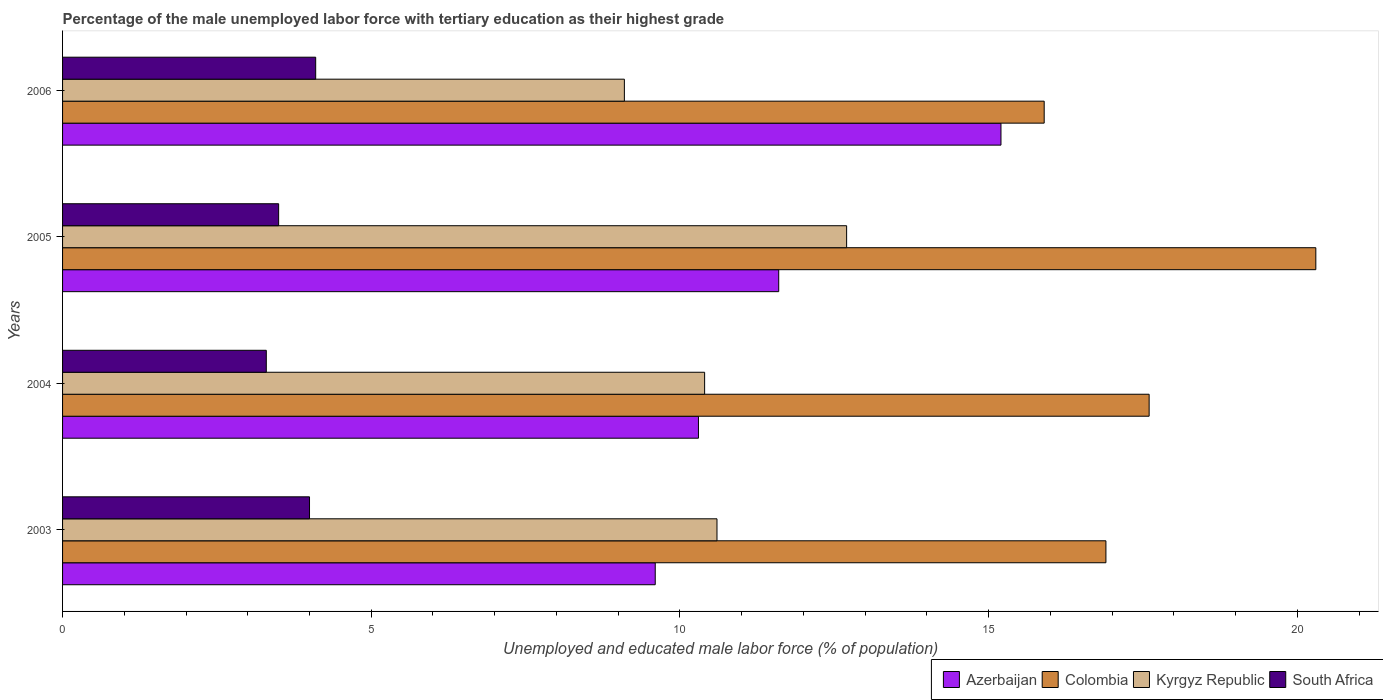How many groups of bars are there?
Your response must be concise. 4. Are the number of bars on each tick of the Y-axis equal?
Your answer should be very brief. Yes. How many bars are there on the 1st tick from the top?
Your response must be concise. 4. Across all years, what is the maximum percentage of the unemployed male labor force with tertiary education in Colombia?
Make the answer very short. 20.3. Across all years, what is the minimum percentage of the unemployed male labor force with tertiary education in South Africa?
Offer a terse response. 3.3. In which year was the percentage of the unemployed male labor force with tertiary education in Kyrgyz Republic maximum?
Your response must be concise. 2005. In which year was the percentage of the unemployed male labor force with tertiary education in Colombia minimum?
Your answer should be very brief. 2006. What is the total percentage of the unemployed male labor force with tertiary education in Kyrgyz Republic in the graph?
Offer a very short reply. 42.8. What is the difference between the percentage of the unemployed male labor force with tertiary education in Azerbaijan in 2005 and that in 2006?
Your answer should be very brief. -3.6. What is the difference between the percentage of the unemployed male labor force with tertiary education in Kyrgyz Republic in 2005 and the percentage of the unemployed male labor force with tertiary education in Azerbaijan in 2003?
Your answer should be compact. 3.1. What is the average percentage of the unemployed male labor force with tertiary education in Azerbaijan per year?
Offer a terse response. 11.68. In the year 2005, what is the difference between the percentage of the unemployed male labor force with tertiary education in Azerbaijan and percentage of the unemployed male labor force with tertiary education in Colombia?
Offer a very short reply. -8.7. In how many years, is the percentage of the unemployed male labor force with tertiary education in Kyrgyz Republic greater than 1 %?
Offer a very short reply. 4. What is the ratio of the percentage of the unemployed male labor force with tertiary education in Kyrgyz Republic in 2003 to that in 2004?
Make the answer very short. 1.02. Is the percentage of the unemployed male labor force with tertiary education in Colombia in 2004 less than that in 2006?
Provide a succinct answer. No. What is the difference between the highest and the second highest percentage of the unemployed male labor force with tertiary education in Colombia?
Ensure brevity in your answer.  2.7. What is the difference between the highest and the lowest percentage of the unemployed male labor force with tertiary education in Azerbaijan?
Your answer should be compact. 5.6. In how many years, is the percentage of the unemployed male labor force with tertiary education in Kyrgyz Republic greater than the average percentage of the unemployed male labor force with tertiary education in Kyrgyz Republic taken over all years?
Offer a terse response. 1. Is it the case that in every year, the sum of the percentage of the unemployed male labor force with tertiary education in Azerbaijan and percentage of the unemployed male labor force with tertiary education in Colombia is greater than the sum of percentage of the unemployed male labor force with tertiary education in South Africa and percentage of the unemployed male labor force with tertiary education in Kyrgyz Republic?
Provide a succinct answer. No. What does the 2nd bar from the top in 2006 represents?
Your answer should be very brief. Kyrgyz Republic. What does the 1st bar from the bottom in 2006 represents?
Give a very brief answer. Azerbaijan. Are all the bars in the graph horizontal?
Make the answer very short. Yes. What is the difference between two consecutive major ticks on the X-axis?
Keep it short and to the point. 5. Are the values on the major ticks of X-axis written in scientific E-notation?
Provide a short and direct response. No. How many legend labels are there?
Your answer should be compact. 4. How are the legend labels stacked?
Provide a short and direct response. Horizontal. What is the title of the graph?
Keep it short and to the point. Percentage of the male unemployed labor force with tertiary education as their highest grade. What is the label or title of the X-axis?
Your answer should be very brief. Unemployed and educated male labor force (% of population). What is the label or title of the Y-axis?
Keep it short and to the point. Years. What is the Unemployed and educated male labor force (% of population) in Azerbaijan in 2003?
Your answer should be compact. 9.6. What is the Unemployed and educated male labor force (% of population) of Colombia in 2003?
Make the answer very short. 16.9. What is the Unemployed and educated male labor force (% of population) in Kyrgyz Republic in 2003?
Your answer should be very brief. 10.6. What is the Unemployed and educated male labor force (% of population) in South Africa in 2003?
Your answer should be compact. 4. What is the Unemployed and educated male labor force (% of population) of Azerbaijan in 2004?
Ensure brevity in your answer.  10.3. What is the Unemployed and educated male labor force (% of population) of Colombia in 2004?
Give a very brief answer. 17.6. What is the Unemployed and educated male labor force (% of population) in Kyrgyz Republic in 2004?
Give a very brief answer. 10.4. What is the Unemployed and educated male labor force (% of population) of South Africa in 2004?
Keep it short and to the point. 3.3. What is the Unemployed and educated male labor force (% of population) in Azerbaijan in 2005?
Keep it short and to the point. 11.6. What is the Unemployed and educated male labor force (% of population) of Colombia in 2005?
Offer a terse response. 20.3. What is the Unemployed and educated male labor force (% of population) of Kyrgyz Republic in 2005?
Your answer should be very brief. 12.7. What is the Unemployed and educated male labor force (% of population) of Azerbaijan in 2006?
Your response must be concise. 15.2. What is the Unemployed and educated male labor force (% of population) of Colombia in 2006?
Your answer should be very brief. 15.9. What is the Unemployed and educated male labor force (% of population) in Kyrgyz Republic in 2006?
Offer a terse response. 9.1. What is the Unemployed and educated male labor force (% of population) in South Africa in 2006?
Keep it short and to the point. 4.1. Across all years, what is the maximum Unemployed and educated male labor force (% of population) of Azerbaijan?
Provide a short and direct response. 15.2. Across all years, what is the maximum Unemployed and educated male labor force (% of population) of Colombia?
Make the answer very short. 20.3. Across all years, what is the maximum Unemployed and educated male labor force (% of population) in Kyrgyz Republic?
Provide a succinct answer. 12.7. Across all years, what is the maximum Unemployed and educated male labor force (% of population) in South Africa?
Give a very brief answer. 4.1. Across all years, what is the minimum Unemployed and educated male labor force (% of population) in Azerbaijan?
Provide a short and direct response. 9.6. Across all years, what is the minimum Unemployed and educated male labor force (% of population) in Colombia?
Provide a succinct answer. 15.9. Across all years, what is the minimum Unemployed and educated male labor force (% of population) of Kyrgyz Republic?
Give a very brief answer. 9.1. Across all years, what is the minimum Unemployed and educated male labor force (% of population) of South Africa?
Provide a succinct answer. 3.3. What is the total Unemployed and educated male labor force (% of population) in Azerbaijan in the graph?
Provide a short and direct response. 46.7. What is the total Unemployed and educated male labor force (% of population) of Colombia in the graph?
Give a very brief answer. 70.7. What is the total Unemployed and educated male labor force (% of population) of Kyrgyz Republic in the graph?
Give a very brief answer. 42.8. What is the total Unemployed and educated male labor force (% of population) in South Africa in the graph?
Offer a very short reply. 14.9. What is the difference between the Unemployed and educated male labor force (% of population) in Azerbaijan in 2003 and that in 2004?
Keep it short and to the point. -0.7. What is the difference between the Unemployed and educated male labor force (% of population) of Kyrgyz Republic in 2003 and that in 2005?
Give a very brief answer. -2.1. What is the difference between the Unemployed and educated male labor force (% of population) of South Africa in 2003 and that in 2005?
Your response must be concise. 0.5. What is the difference between the Unemployed and educated male labor force (% of population) of Azerbaijan in 2003 and that in 2006?
Your answer should be very brief. -5.6. What is the difference between the Unemployed and educated male labor force (% of population) in Azerbaijan in 2004 and that in 2005?
Your response must be concise. -1.3. What is the difference between the Unemployed and educated male labor force (% of population) of Colombia in 2004 and that in 2005?
Your response must be concise. -2.7. What is the difference between the Unemployed and educated male labor force (% of population) in Kyrgyz Republic in 2004 and that in 2005?
Offer a terse response. -2.3. What is the difference between the Unemployed and educated male labor force (% of population) in South Africa in 2004 and that in 2005?
Provide a short and direct response. -0.2. What is the difference between the Unemployed and educated male labor force (% of population) of Azerbaijan in 2004 and that in 2006?
Make the answer very short. -4.9. What is the difference between the Unemployed and educated male labor force (% of population) in Colombia in 2004 and that in 2006?
Ensure brevity in your answer.  1.7. What is the difference between the Unemployed and educated male labor force (% of population) in South Africa in 2004 and that in 2006?
Provide a succinct answer. -0.8. What is the difference between the Unemployed and educated male labor force (% of population) in Azerbaijan in 2005 and that in 2006?
Offer a very short reply. -3.6. What is the difference between the Unemployed and educated male labor force (% of population) of South Africa in 2005 and that in 2006?
Your response must be concise. -0.6. What is the difference between the Unemployed and educated male labor force (% of population) in Azerbaijan in 2003 and the Unemployed and educated male labor force (% of population) in South Africa in 2004?
Your response must be concise. 6.3. What is the difference between the Unemployed and educated male labor force (% of population) of Colombia in 2003 and the Unemployed and educated male labor force (% of population) of Kyrgyz Republic in 2004?
Provide a succinct answer. 6.5. What is the difference between the Unemployed and educated male labor force (% of population) of Colombia in 2003 and the Unemployed and educated male labor force (% of population) of South Africa in 2004?
Provide a succinct answer. 13.6. What is the difference between the Unemployed and educated male labor force (% of population) of Azerbaijan in 2003 and the Unemployed and educated male labor force (% of population) of Kyrgyz Republic in 2005?
Your answer should be very brief. -3.1. What is the difference between the Unemployed and educated male labor force (% of population) of Azerbaijan in 2003 and the Unemployed and educated male labor force (% of population) of South Africa in 2005?
Give a very brief answer. 6.1. What is the difference between the Unemployed and educated male labor force (% of population) of Colombia in 2003 and the Unemployed and educated male labor force (% of population) of South Africa in 2005?
Make the answer very short. 13.4. What is the difference between the Unemployed and educated male labor force (% of population) of Kyrgyz Republic in 2003 and the Unemployed and educated male labor force (% of population) of South Africa in 2005?
Ensure brevity in your answer.  7.1. What is the difference between the Unemployed and educated male labor force (% of population) of Azerbaijan in 2003 and the Unemployed and educated male labor force (% of population) of Colombia in 2006?
Keep it short and to the point. -6.3. What is the difference between the Unemployed and educated male labor force (% of population) of Azerbaijan in 2003 and the Unemployed and educated male labor force (% of population) of Kyrgyz Republic in 2006?
Your response must be concise. 0.5. What is the difference between the Unemployed and educated male labor force (% of population) in Colombia in 2003 and the Unemployed and educated male labor force (% of population) in South Africa in 2006?
Provide a short and direct response. 12.8. What is the difference between the Unemployed and educated male labor force (% of population) in Azerbaijan in 2004 and the Unemployed and educated male labor force (% of population) in South Africa in 2005?
Provide a succinct answer. 6.8. What is the difference between the Unemployed and educated male labor force (% of population) in Colombia in 2004 and the Unemployed and educated male labor force (% of population) in Kyrgyz Republic in 2005?
Make the answer very short. 4.9. What is the difference between the Unemployed and educated male labor force (% of population) in Azerbaijan in 2004 and the Unemployed and educated male labor force (% of population) in Kyrgyz Republic in 2006?
Your response must be concise. 1.2. What is the difference between the Unemployed and educated male labor force (% of population) in Colombia in 2004 and the Unemployed and educated male labor force (% of population) in South Africa in 2006?
Make the answer very short. 13.5. What is the difference between the Unemployed and educated male labor force (% of population) of Azerbaijan in 2005 and the Unemployed and educated male labor force (% of population) of Colombia in 2006?
Provide a short and direct response. -4.3. What is the difference between the Unemployed and educated male labor force (% of population) in Azerbaijan in 2005 and the Unemployed and educated male labor force (% of population) in South Africa in 2006?
Offer a terse response. 7.5. What is the difference between the Unemployed and educated male labor force (% of population) of Colombia in 2005 and the Unemployed and educated male labor force (% of population) of South Africa in 2006?
Provide a succinct answer. 16.2. What is the difference between the Unemployed and educated male labor force (% of population) of Kyrgyz Republic in 2005 and the Unemployed and educated male labor force (% of population) of South Africa in 2006?
Make the answer very short. 8.6. What is the average Unemployed and educated male labor force (% of population) of Azerbaijan per year?
Offer a very short reply. 11.68. What is the average Unemployed and educated male labor force (% of population) of Colombia per year?
Ensure brevity in your answer.  17.68. What is the average Unemployed and educated male labor force (% of population) in South Africa per year?
Your answer should be very brief. 3.73. In the year 2003, what is the difference between the Unemployed and educated male labor force (% of population) of Azerbaijan and Unemployed and educated male labor force (% of population) of Colombia?
Provide a short and direct response. -7.3. In the year 2003, what is the difference between the Unemployed and educated male labor force (% of population) of Azerbaijan and Unemployed and educated male labor force (% of population) of Kyrgyz Republic?
Your answer should be very brief. -1. In the year 2003, what is the difference between the Unemployed and educated male labor force (% of population) in Azerbaijan and Unemployed and educated male labor force (% of population) in South Africa?
Your response must be concise. 5.6. In the year 2003, what is the difference between the Unemployed and educated male labor force (% of population) in Colombia and Unemployed and educated male labor force (% of population) in Kyrgyz Republic?
Make the answer very short. 6.3. In the year 2003, what is the difference between the Unemployed and educated male labor force (% of population) of Colombia and Unemployed and educated male labor force (% of population) of South Africa?
Offer a very short reply. 12.9. In the year 2003, what is the difference between the Unemployed and educated male labor force (% of population) of Kyrgyz Republic and Unemployed and educated male labor force (% of population) of South Africa?
Give a very brief answer. 6.6. In the year 2004, what is the difference between the Unemployed and educated male labor force (% of population) in Colombia and Unemployed and educated male labor force (% of population) in Kyrgyz Republic?
Your answer should be very brief. 7.2. In the year 2004, what is the difference between the Unemployed and educated male labor force (% of population) of Colombia and Unemployed and educated male labor force (% of population) of South Africa?
Offer a terse response. 14.3. In the year 2004, what is the difference between the Unemployed and educated male labor force (% of population) of Kyrgyz Republic and Unemployed and educated male labor force (% of population) of South Africa?
Your answer should be compact. 7.1. In the year 2005, what is the difference between the Unemployed and educated male labor force (% of population) in Azerbaijan and Unemployed and educated male labor force (% of population) in Kyrgyz Republic?
Your response must be concise. -1.1. In the year 2005, what is the difference between the Unemployed and educated male labor force (% of population) of Colombia and Unemployed and educated male labor force (% of population) of Kyrgyz Republic?
Give a very brief answer. 7.6. In the year 2005, what is the difference between the Unemployed and educated male labor force (% of population) in Colombia and Unemployed and educated male labor force (% of population) in South Africa?
Offer a very short reply. 16.8. In the year 2005, what is the difference between the Unemployed and educated male labor force (% of population) of Kyrgyz Republic and Unemployed and educated male labor force (% of population) of South Africa?
Your answer should be compact. 9.2. In the year 2006, what is the difference between the Unemployed and educated male labor force (% of population) in Azerbaijan and Unemployed and educated male labor force (% of population) in Colombia?
Provide a succinct answer. -0.7. In the year 2006, what is the difference between the Unemployed and educated male labor force (% of population) of Azerbaijan and Unemployed and educated male labor force (% of population) of Kyrgyz Republic?
Keep it short and to the point. 6.1. In the year 2006, what is the difference between the Unemployed and educated male labor force (% of population) of Azerbaijan and Unemployed and educated male labor force (% of population) of South Africa?
Your response must be concise. 11.1. What is the ratio of the Unemployed and educated male labor force (% of population) of Azerbaijan in 2003 to that in 2004?
Provide a succinct answer. 0.93. What is the ratio of the Unemployed and educated male labor force (% of population) of Colombia in 2003 to that in 2004?
Make the answer very short. 0.96. What is the ratio of the Unemployed and educated male labor force (% of population) of Kyrgyz Republic in 2003 to that in 2004?
Make the answer very short. 1.02. What is the ratio of the Unemployed and educated male labor force (% of population) in South Africa in 2003 to that in 2004?
Keep it short and to the point. 1.21. What is the ratio of the Unemployed and educated male labor force (% of population) of Azerbaijan in 2003 to that in 2005?
Make the answer very short. 0.83. What is the ratio of the Unemployed and educated male labor force (% of population) in Colombia in 2003 to that in 2005?
Give a very brief answer. 0.83. What is the ratio of the Unemployed and educated male labor force (% of population) of Kyrgyz Republic in 2003 to that in 2005?
Provide a short and direct response. 0.83. What is the ratio of the Unemployed and educated male labor force (% of population) in Azerbaijan in 2003 to that in 2006?
Your answer should be compact. 0.63. What is the ratio of the Unemployed and educated male labor force (% of population) in Colombia in 2003 to that in 2006?
Make the answer very short. 1.06. What is the ratio of the Unemployed and educated male labor force (% of population) in Kyrgyz Republic in 2003 to that in 2006?
Your answer should be very brief. 1.16. What is the ratio of the Unemployed and educated male labor force (% of population) of South Africa in 2003 to that in 2006?
Your answer should be very brief. 0.98. What is the ratio of the Unemployed and educated male labor force (% of population) of Azerbaijan in 2004 to that in 2005?
Make the answer very short. 0.89. What is the ratio of the Unemployed and educated male labor force (% of population) of Colombia in 2004 to that in 2005?
Your response must be concise. 0.87. What is the ratio of the Unemployed and educated male labor force (% of population) in Kyrgyz Republic in 2004 to that in 2005?
Keep it short and to the point. 0.82. What is the ratio of the Unemployed and educated male labor force (% of population) of South Africa in 2004 to that in 2005?
Provide a short and direct response. 0.94. What is the ratio of the Unemployed and educated male labor force (% of population) of Azerbaijan in 2004 to that in 2006?
Offer a very short reply. 0.68. What is the ratio of the Unemployed and educated male labor force (% of population) of Colombia in 2004 to that in 2006?
Offer a terse response. 1.11. What is the ratio of the Unemployed and educated male labor force (% of population) of Kyrgyz Republic in 2004 to that in 2006?
Keep it short and to the point. 1.14. What is the ratio of the Unemployed and educated male labor force (% of population) of South Africa in 2004 to that in 2006?
Keep it short and to the point. 0.8. What is the ratio of the Unemployed and educated male labor force (% of population) in Azerbaijan in 2005 to that in 2006?
Ensure brevity in your answer.  0.76. What is the ratio of the Unemployed and educated male labor force (% of population) of Colombia in 2005 to that in 2006?
Your answer should be compact. 1.28. What is the ratio of the Unemployed and educated male labor force (% of population) in Kyrgyz Republic in 2005 to that in 2006?
Your answer should be very brief. 1.4. What is the ratio of the Unemployed and educated male labor force (% of population) in South Africa in 2005 to that in 2006?
Ensure brevity in your answer.  0.85. What is the difference between the highest and the second highest Unemployed and educated male labor force (% of population) of Azerbaijan?
Offer a very short reply. 3.6. What is the difference between the highest and the second highest Unemployed and educated male labor force (% of population) in Kyrgyz Republic?
Your answer should be compact. 2.1. What is the difference between the highest and the second highest Unemployed and educated male labor force (% of population) in South Africa?
Offer a terse response. 0.1. What is the difference between the highest and the lowest Unemployed and educated male labor force (% of population) of Azerbaijan?
Offer a very short reply. 5.6. What is the difference between the highest and the lowest Unemployed and educated male labor force (% of population) of South Africa?
Give a very brief answer. 0.8. 